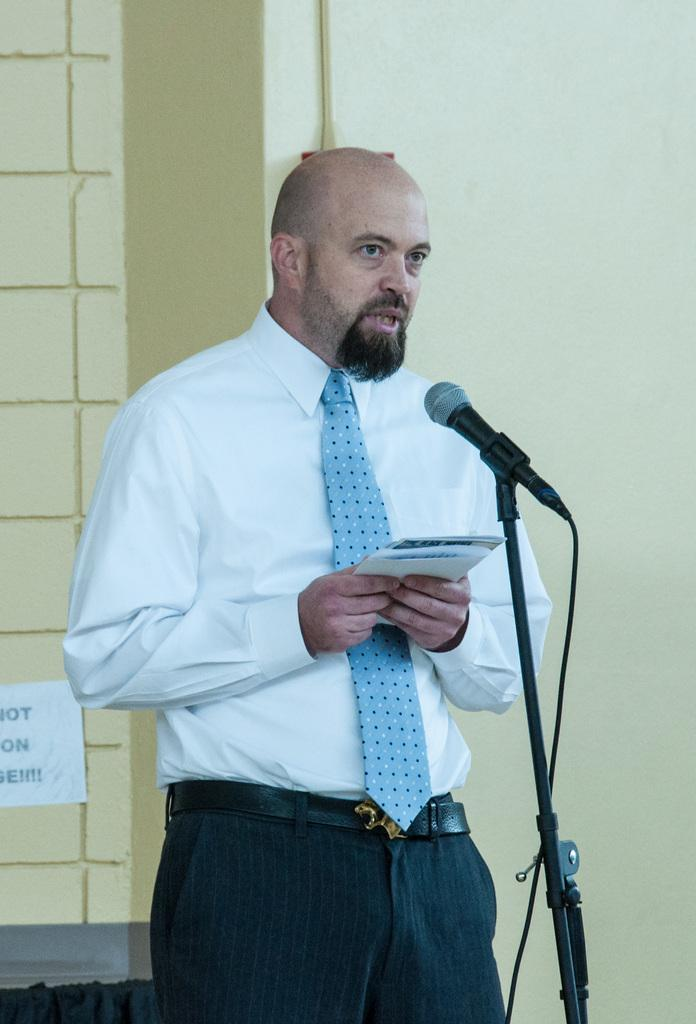Who is present in the image? There is a man in the image. What is the man holding in the image? The man is holding papers. What object is in front of the man? There is a microphone in front of the man. What can be seen on the wall in the background of the image? There is a pipe on the wall in the background of the image. What type of grass is growing around the man in the image? There is no grass present in the image; it is an indoor setting with a man, papers, a microphone, and a pipe on the wall. 